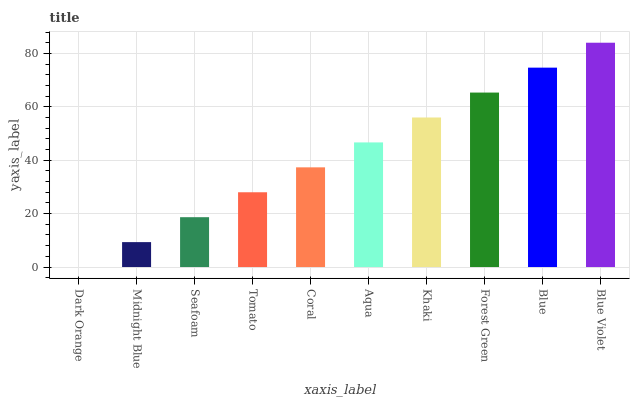Is Midnight Blue the minimum?
Answer yes or no. No. Is Midnight Blue the maximum?
Answer yes or no. No. Is Midnight Blue greater than Dark Orange?
Answer yes or no. Yes. Is Dark Orange less than Midnight Blue?
Answer yes or no. Yes. Is Dark Orange greater than Midnight Blue?
Answer yes or no. No. Is Midnight Blue less than Dark Orange?
Answer yes or no. No. Is Aqua the high median?
Answer yes or no. Yes. Is Coral the low median?
Answer yes or no. Yes. Is Khaki the high median?
Answer yes or no. No. Is Dark Orange the low median?
Answer yes or no. No. 